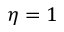<formula> <loc_0><loc_0><loc_500><loc_500>\eta = 1</formula> 